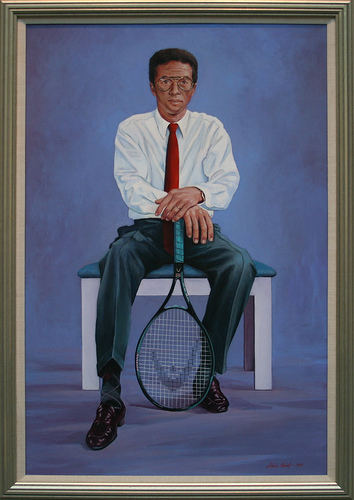Please provide the bounding box coordinate of the region this sentence describes: man sits on blue cushion. The region described by 'the man sits on a blue cushion' is approximately within the coordinates [0.27, 0.46, 0.73, 0.64]. 